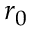Convert formula to latex. <formula><loc_0><loc_0><loc_500><loc_500>r _ { 0 }</formula> 